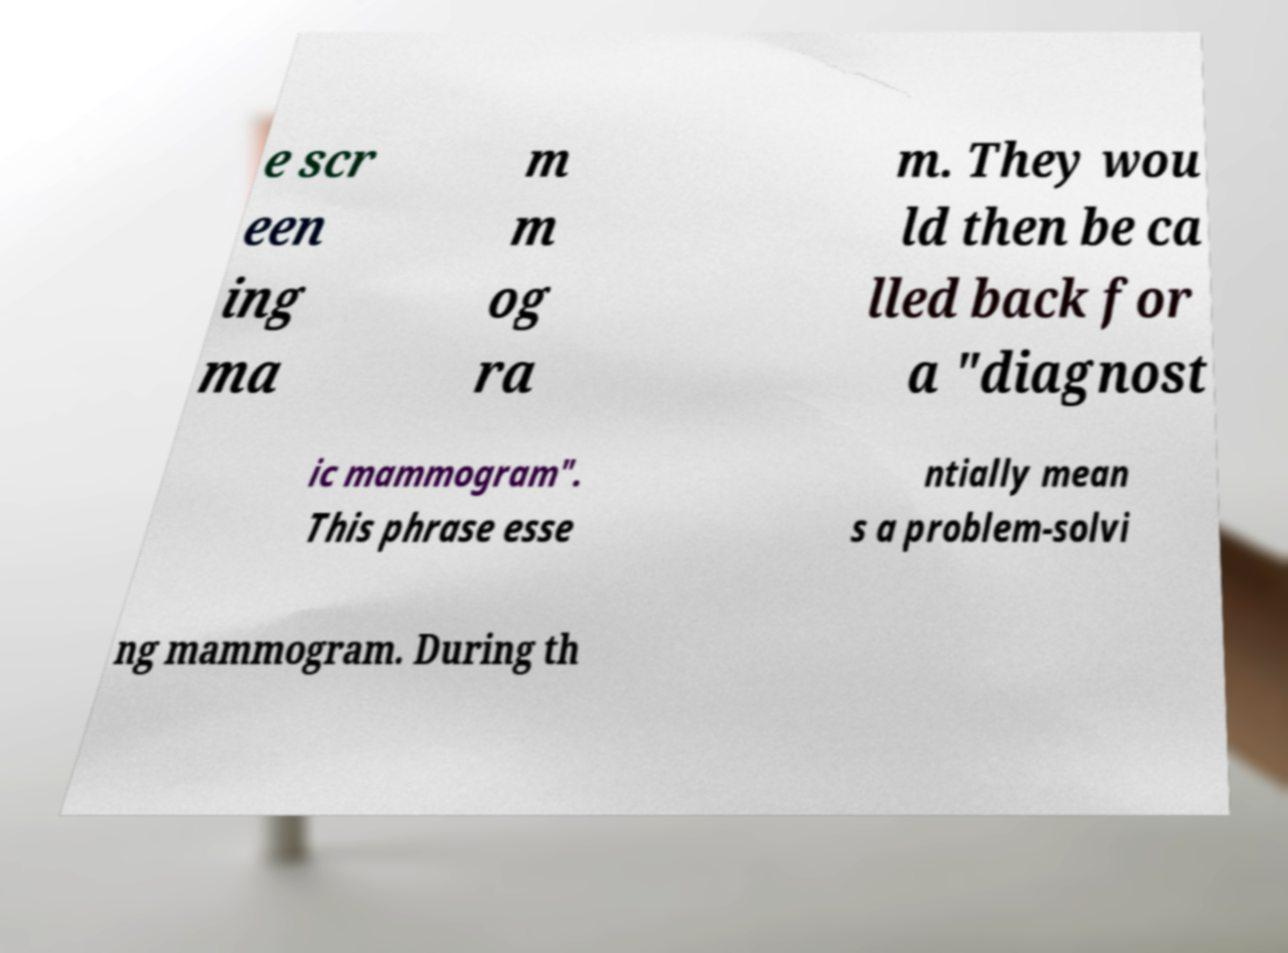There's text embedded in this image that I need extracted. Can you transcribe it verbatim? e scr een ing ma m m og ra m. They wou ld then be ca lled back for a "diagnost ic mammogram". This phrase esse ntially mean s a problem-solvi ng mammogram. During th 